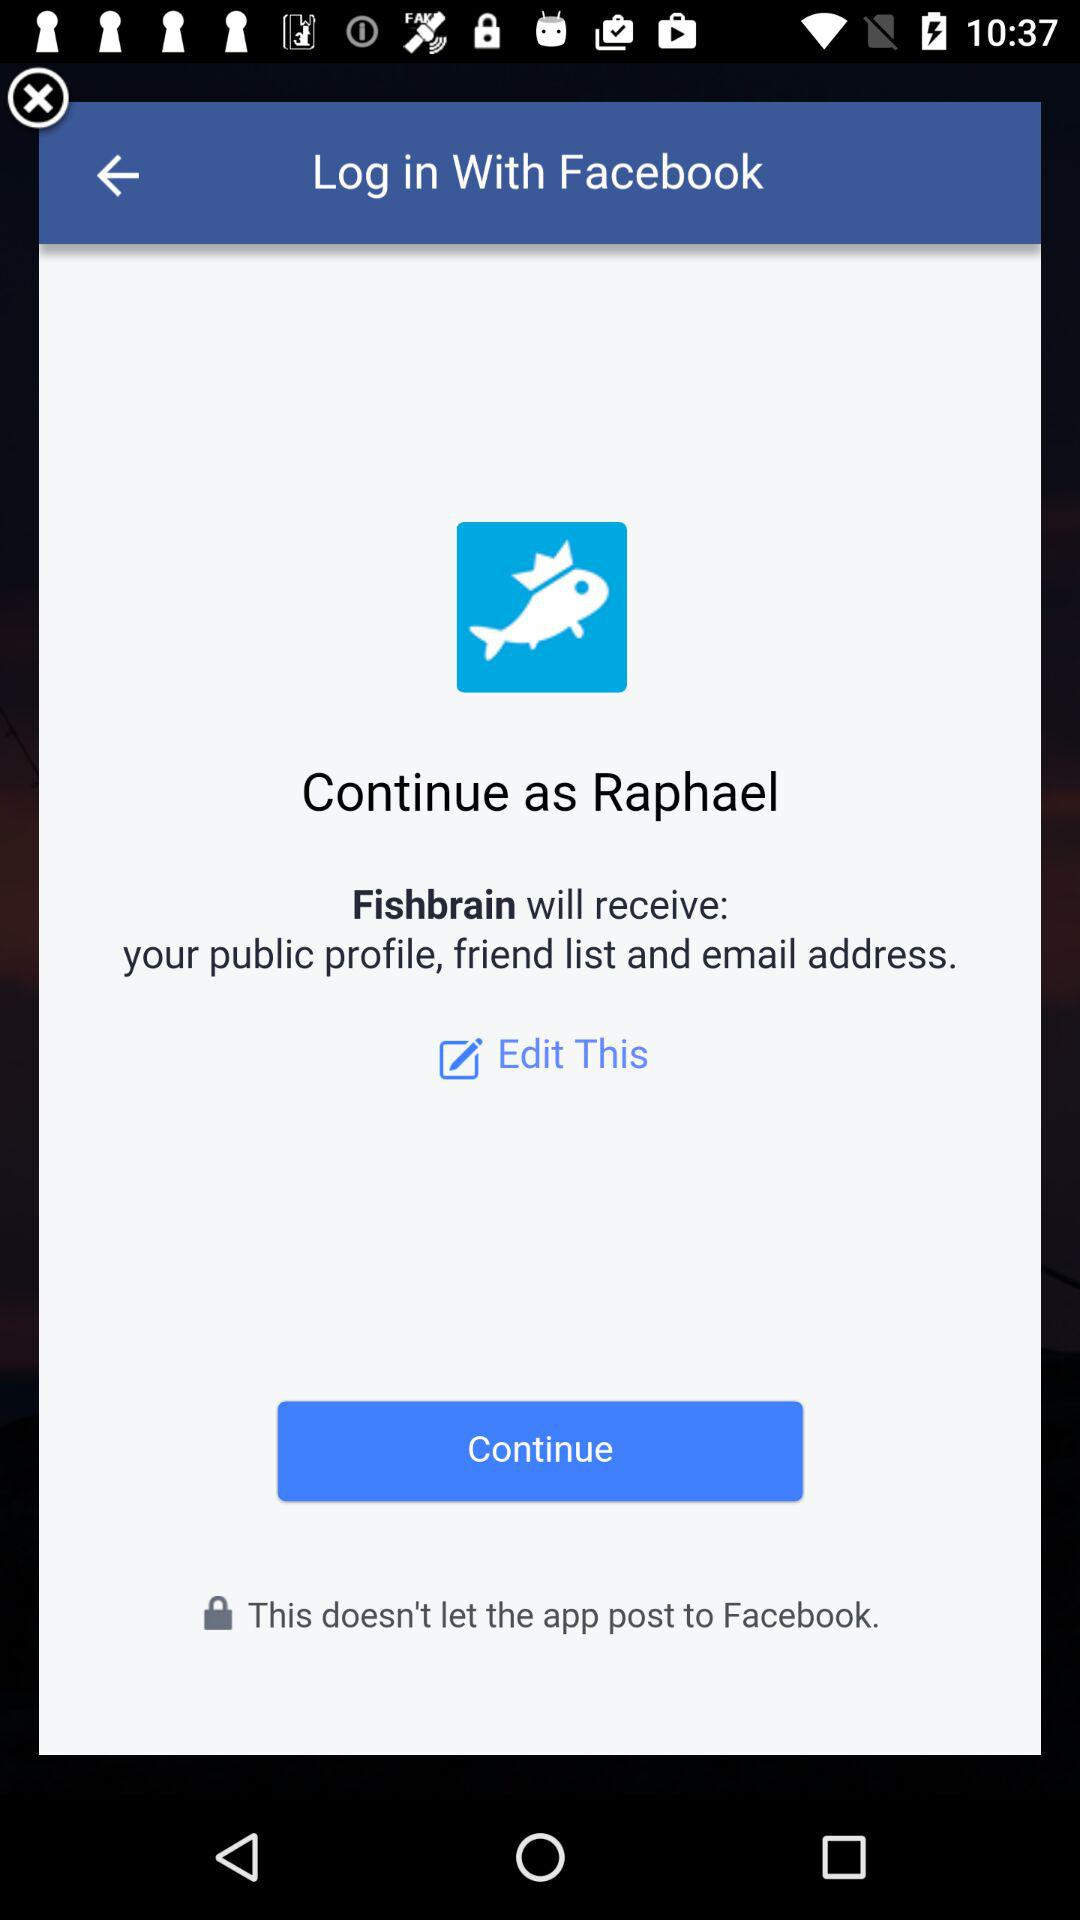What is the user name? The user name is Raphael. 